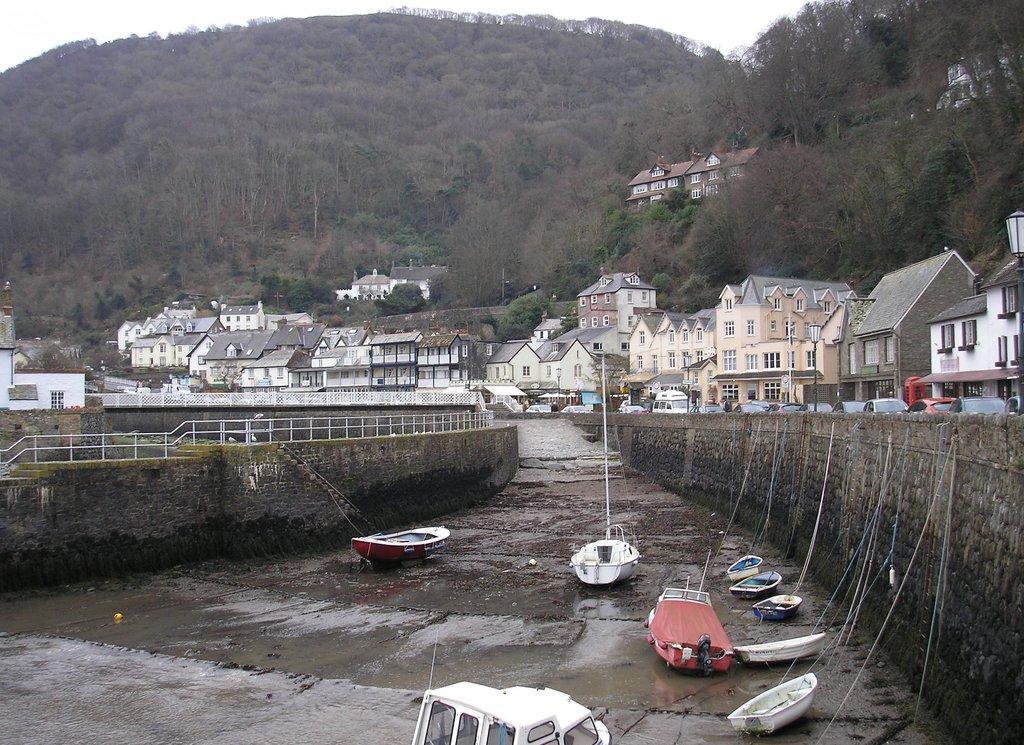Describe this image in one or two sentences. In this image on the right side and left side there are some buildings and some houses, vehicles, wall and railing. At the bottom there are some boats, water and mud. In the background there are trees and mountains. 